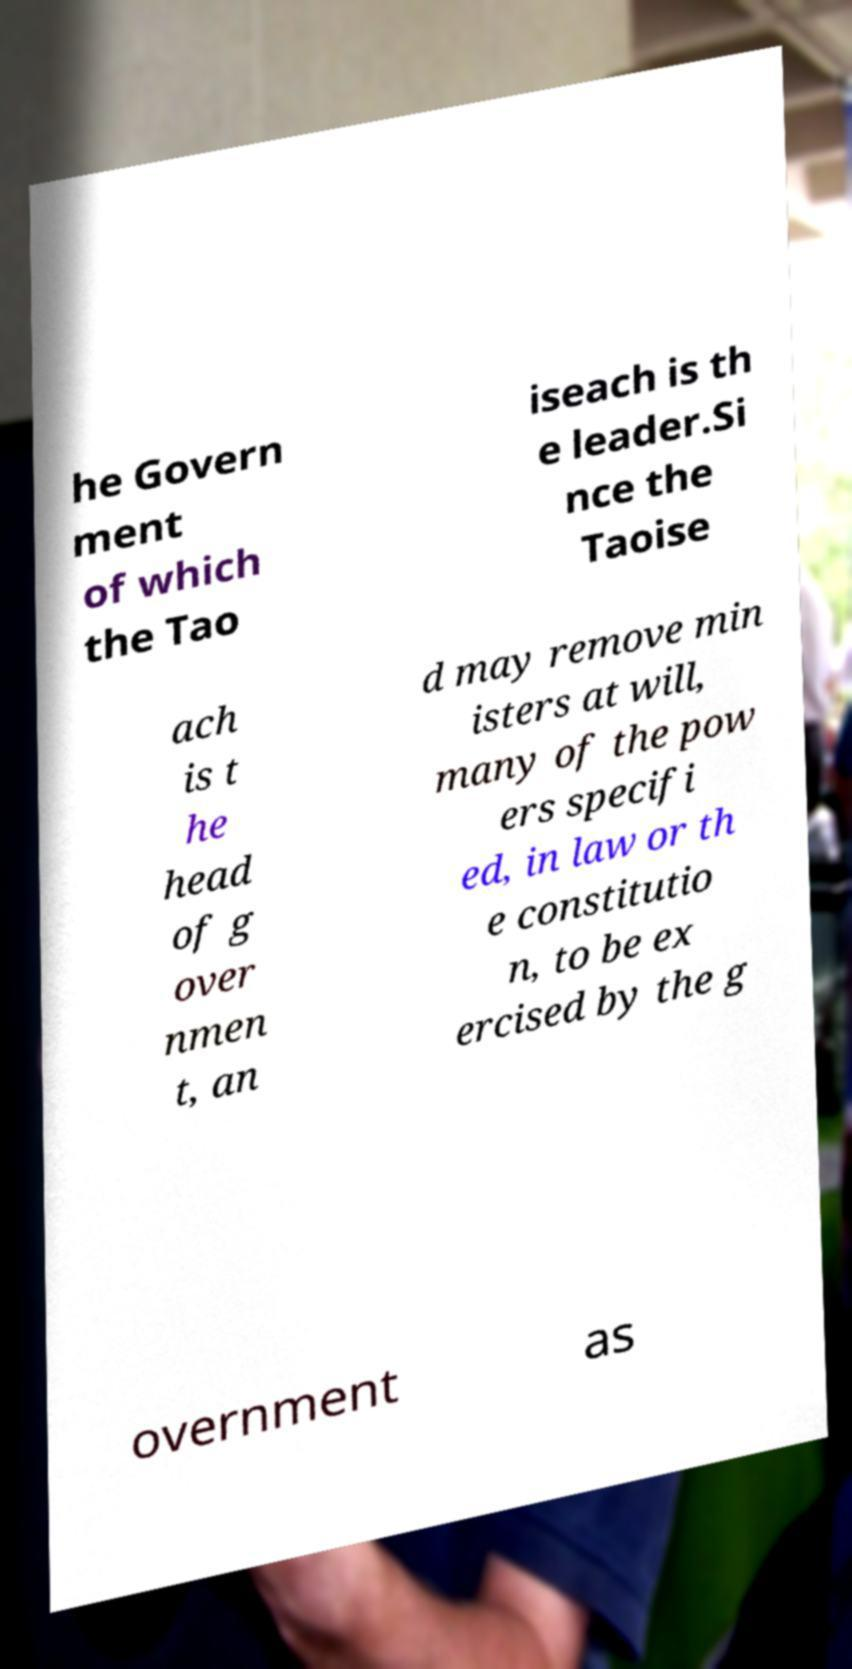For documentation purposes, I need the text within this image transcribed. Could you provide that? he Govern ment of which the Tao iseach is th e leader.Si nce the Taoise ach is t he head of g over nmen t, an d may remove min isters at will, many of the pow ers specifi ed, in law or th e constitutio n, to be ex ercised by the g overnment as 